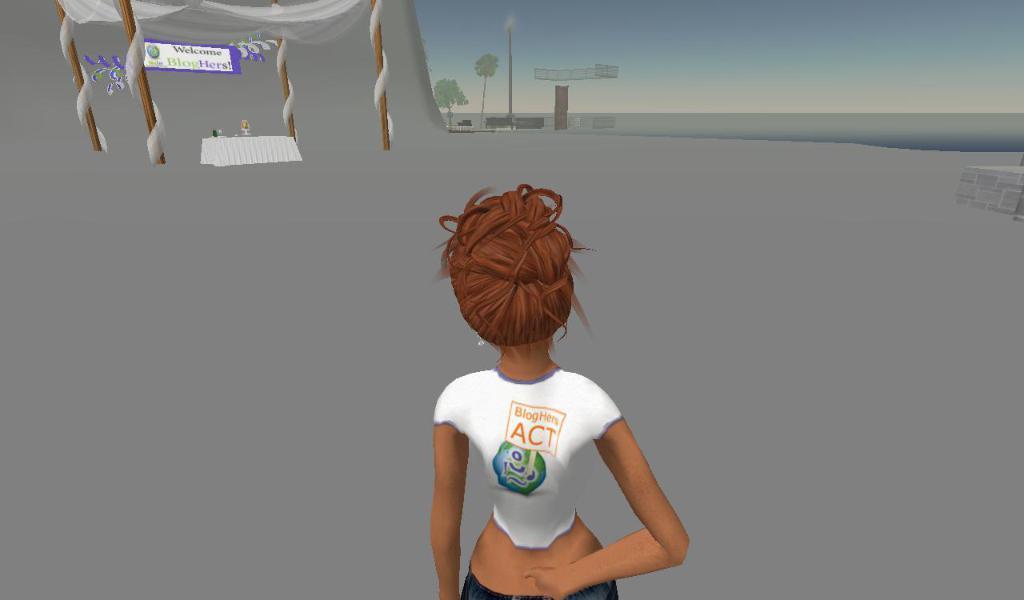Could you give a brief overview of what you see in this image? This image is an animated image. At the top of the image there is a sky. In the middle of the image there is a woman. In the background there is a wall. There is a board with a text on it. There is a table with a few things on it. 